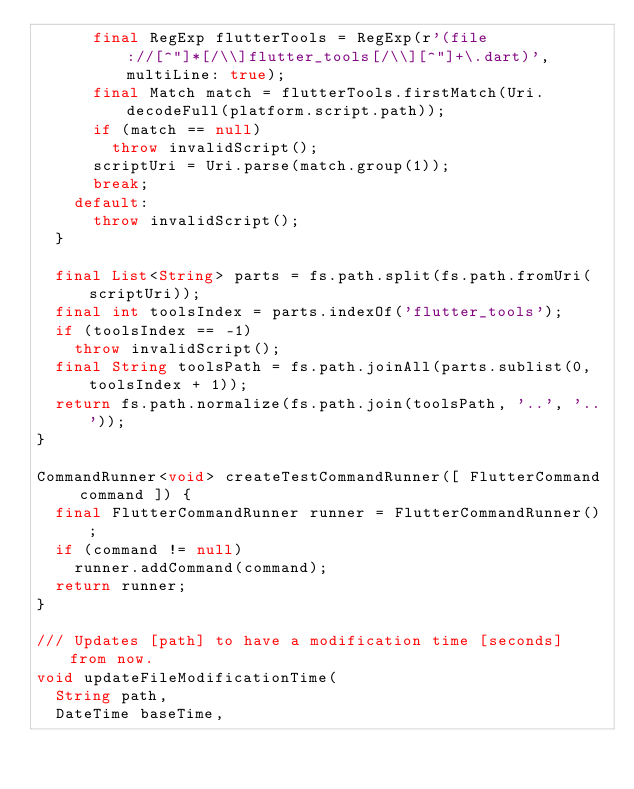Convert code to text. <code><loc_0><loc_0><loc_500><loc_500><_Dart_>      final RegExp flutterTools = RegExp(r'(file://[^"]*[/\\]flutter_tools[/\\][^"]+\.dart)', multiLine: true);
      final Match match = flutterTools.firstMatch(Uri.decodeFull(platform.script.path));
      if (match == null)
        throw invalidScript();
      scriptUri = Uri.parse(match.group(1));
      break;
    default:
      throw invalidScript();
  }

  final List<String> parts = fs.path.split(fs.path.fromUri(scriptUri));
  final int toolsIndex = parts.indexOf('flutter_tools');
  if (toolsIndex == -1)
    throw invalidScript();
  final String toolsPath = fs.path.joinAll(parts.sublist(0, toolsIndex + 1));
  return fs.path.normalize(fs.path.join(toolsPath, '..', '..'));
}

CommandRunner<void> createTestCommandRunner([ FlutterCommand command ]) {
  final FlutterCommandRunner runner = FlutterCommandRunner();
  if (command != null)
    runner.addCommand(command);
  return runner;
}

/// Updates [path] to have a modification time [seconds] from now.
void updateFileModificationTime(
  String path,
  DateTime baseTime,</code> 